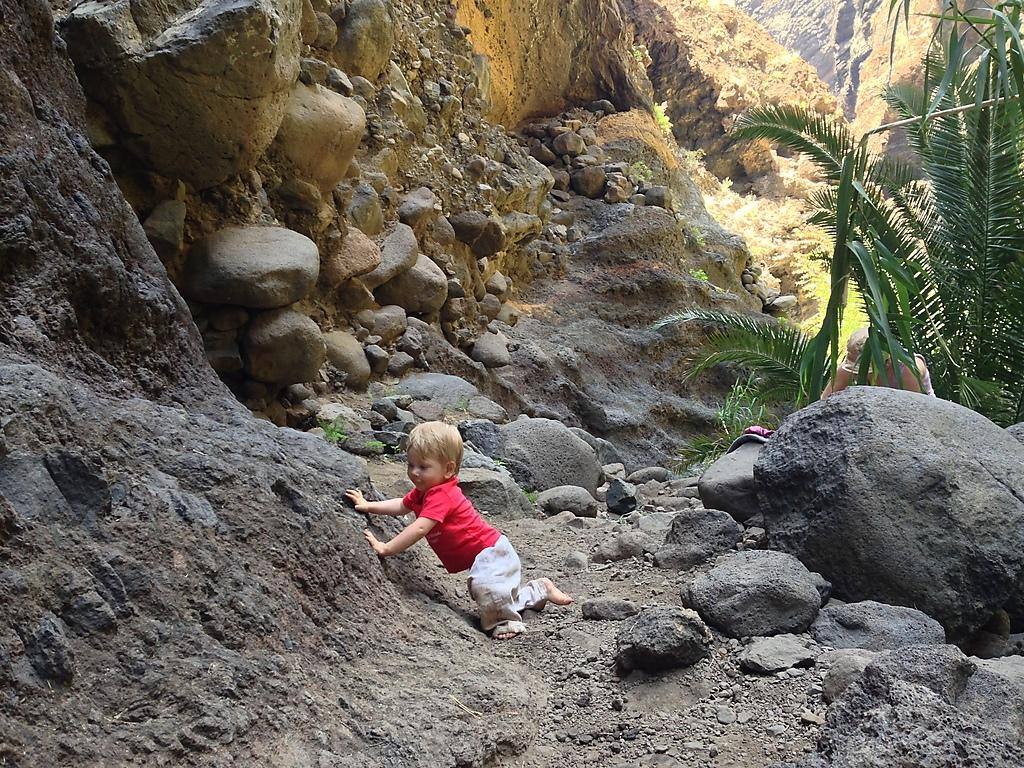Who is the main subject in the image? There is a boy in the image. What is the boy standing on in the image? The boy is on the sand in the image. What other natural elements can be seen in the image? There are rocks and trees visible in the image. What type of terrain is depicted in the image? The sand is present in the image, suggesting a beach or sandy area. What type of wound can be seen on the turkey in the image? There is no turkey present in the image, and therefore no wound can be observed. 